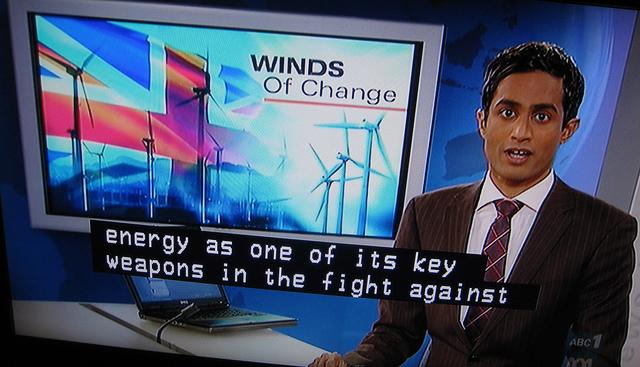Where is this man?
Short answer required. On tv. Is the man sitting on the right a news anchor?
Quick response, please. Yes. Is there more than one screen?
Quick response, please. Yes. What is CBC.CA/news?
Give a very brief answer. News. What TV channel is this?
Concise answer only. Abc1. What do the words on the screen say?
Short answer required. Winds of change. Is the dog enjoying the TV program?
Short answer required. No. Is the man wearing a tie?
Concise answer only. Yes. 